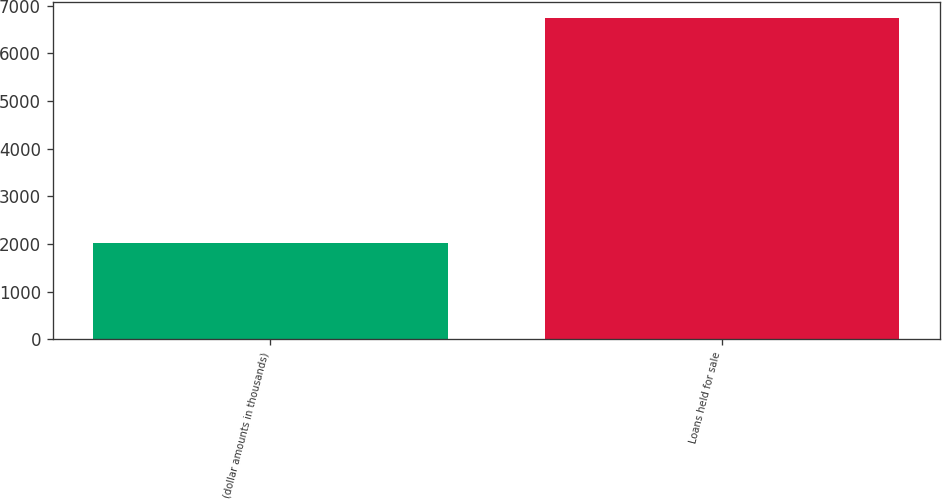Convert chart to OTSL. <chart><loc_0><loc_0><loc_500><loc_500><bar_chart><fcel>(dollar amounts in thousands)<fcel>Loans held for sale<nl><fcel>2016<fcel>6741<nl></chart> 